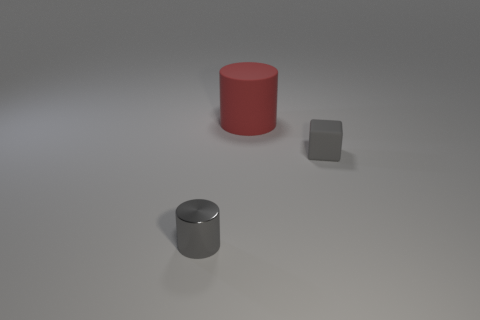Add 2 matte cubes. How many objects exist? 5 Subtract all gray cylinders. How many cylinders are left? 1 Subtract all blocks. How many objects are left? 2 Subtract 1 blocks. How many blocks are left? 0 Subtract all gray cylinders. Subtract all cyan balls. How many cylinders are left? 1 Subtract all cyan blocks. How many gray cylinders are left? 1 Subtract all big rubber objects. Subtract all tiny gray shiny objects. How many objects are left? 1 Add 3 gray metallic objects. How many gray metallic objects are left? 4 Add 1 green metallic cylinders. How many green metallic cylinders exist? 1 Subtract 0 yellow blocks. How many objects are left? 3 